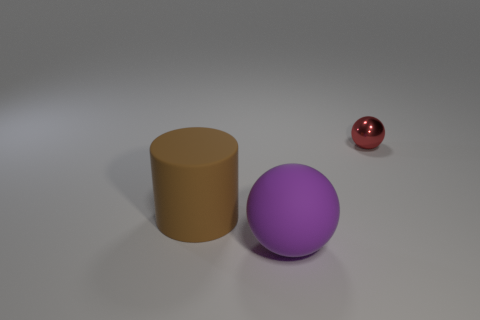Is there any other thing that is the same material as the red ball?
Make the answer very short. No. There is a big cylinder that is made of the same material as the large purple object; what color is it?
Ensure brevity in your answer.  Brown. Is there any other thing that is the same size as the red metallic thing?
Offer a very short reply. No. What number of things are matte things that are on the right side of the rubber cylinder or spheres that are left of the small shiny ball?
Offer a very short reply. 1. There is a sphere that is in front of the big brown cylinder; is its size the same as the sphere behind the big cylinder?
Give a very brief answer. No. The large rubber thing that is the same shape as the tiny red thing is what color?
Your answer should be very brief. Purple. Are there any other things that have the same shape as the brown rubber thing?
Ensure brevity in your answer.  No. Are there more large purple spheres right of the large brown cylinder than tiny red objects left of the shiny object?
Ensure brevity in your answer.  Yes. What size is the matte object that is left of the sphere in front of the ball that is behind the big purple object?
Keep it short and to the point. Large. Does the big purple thing have the same material as the object that is on the left side of the matte sphere?
Your answer should be compact. Yes. 